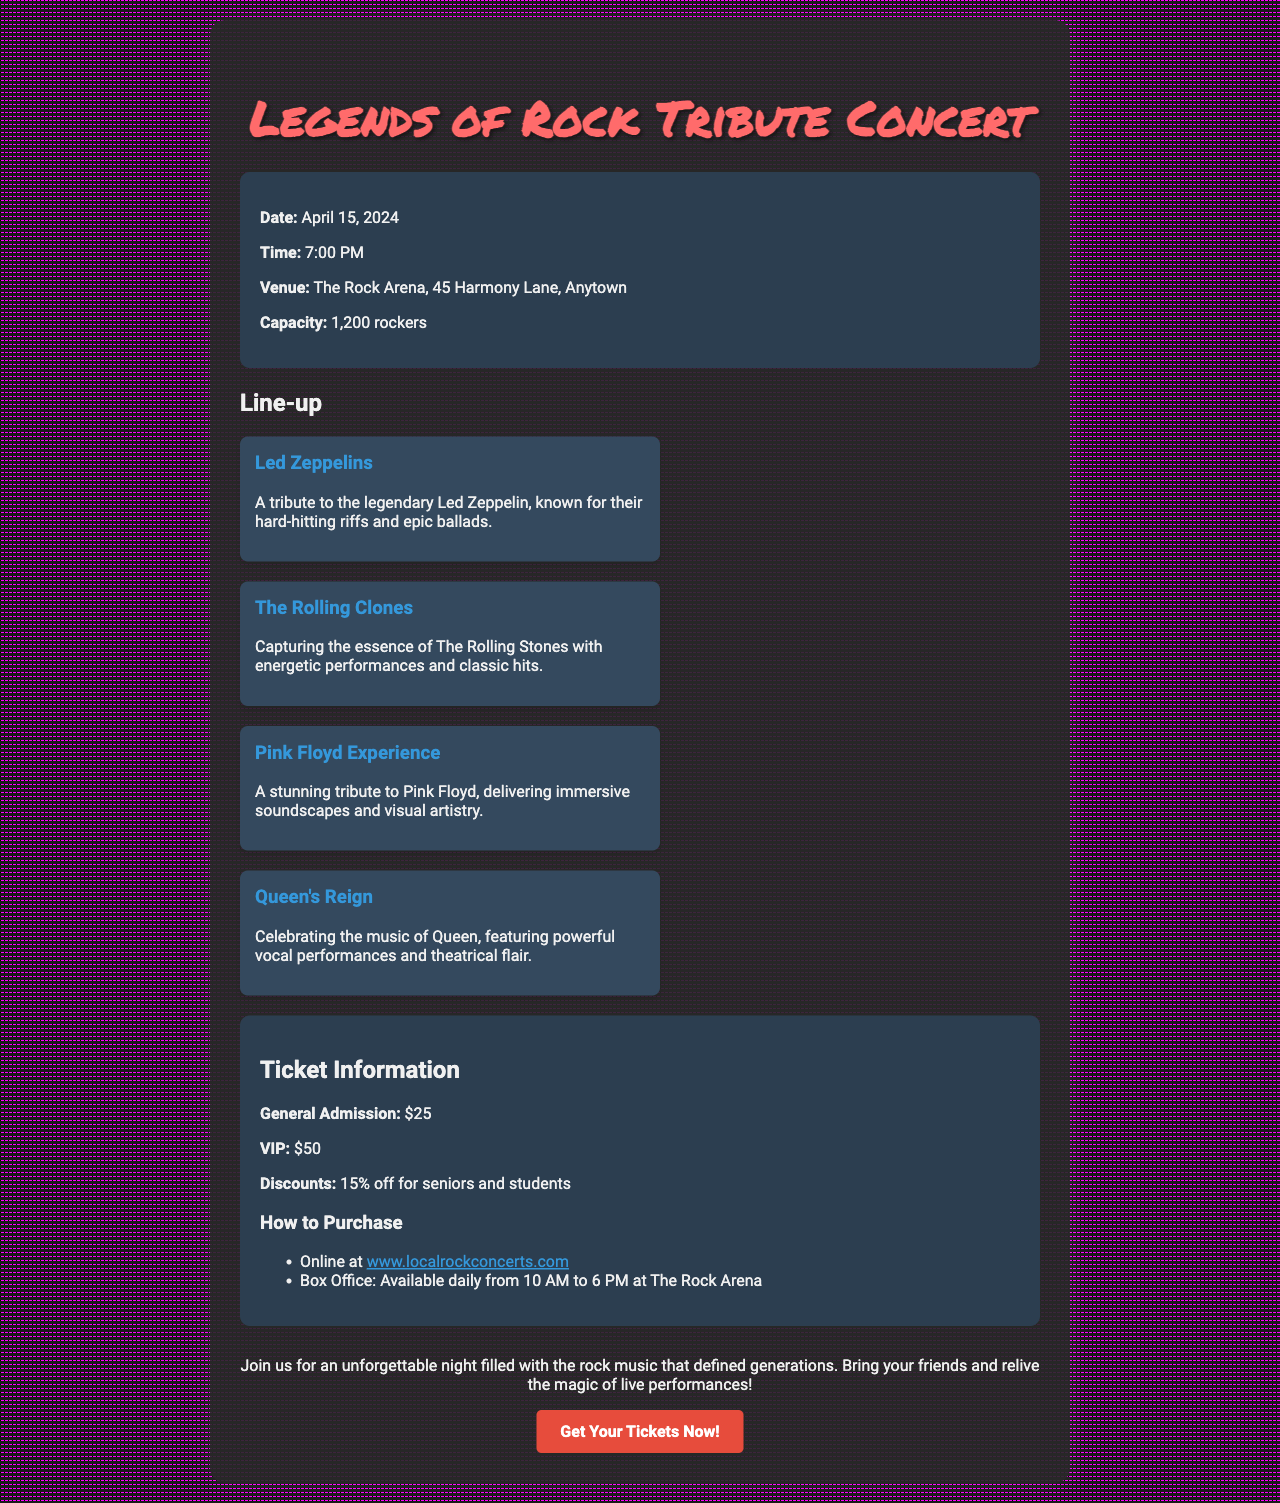What is the date of the concert? The date of the concert is listed in the document as April 15, 2024.
Answer: April 15, 2024 What is the venue of the event? The venue mentioned for the concert is The Rock Arena, 45 Harmony Lane, Anytown.
Answer: The Rock Arena, 45 Harmony Lane, Anytown How many bands are performing at the concert? The document provides information on four tribute bands in the line-up.
Answer: Four What is the price of VIP tickets? The document specifies that VIP tickets are priced at $50.
Answer: $50 Is there a discount available for students? The ticket information states that there is a 15% discount for students.
Answer: 15% off What time does the concert start? The starting time of the concert is mentioned as 7:00 PM.
Answer: 7:00 PM Which band is a tribute to Led Zeppelin? The tribute band for Led Zeppelin is referred to as Led Zeppelins in the lineup section.
Answer: Led Zeppelins What is the general admission ticket price? The document states that general admission tickets are $25.
Answer: $25 